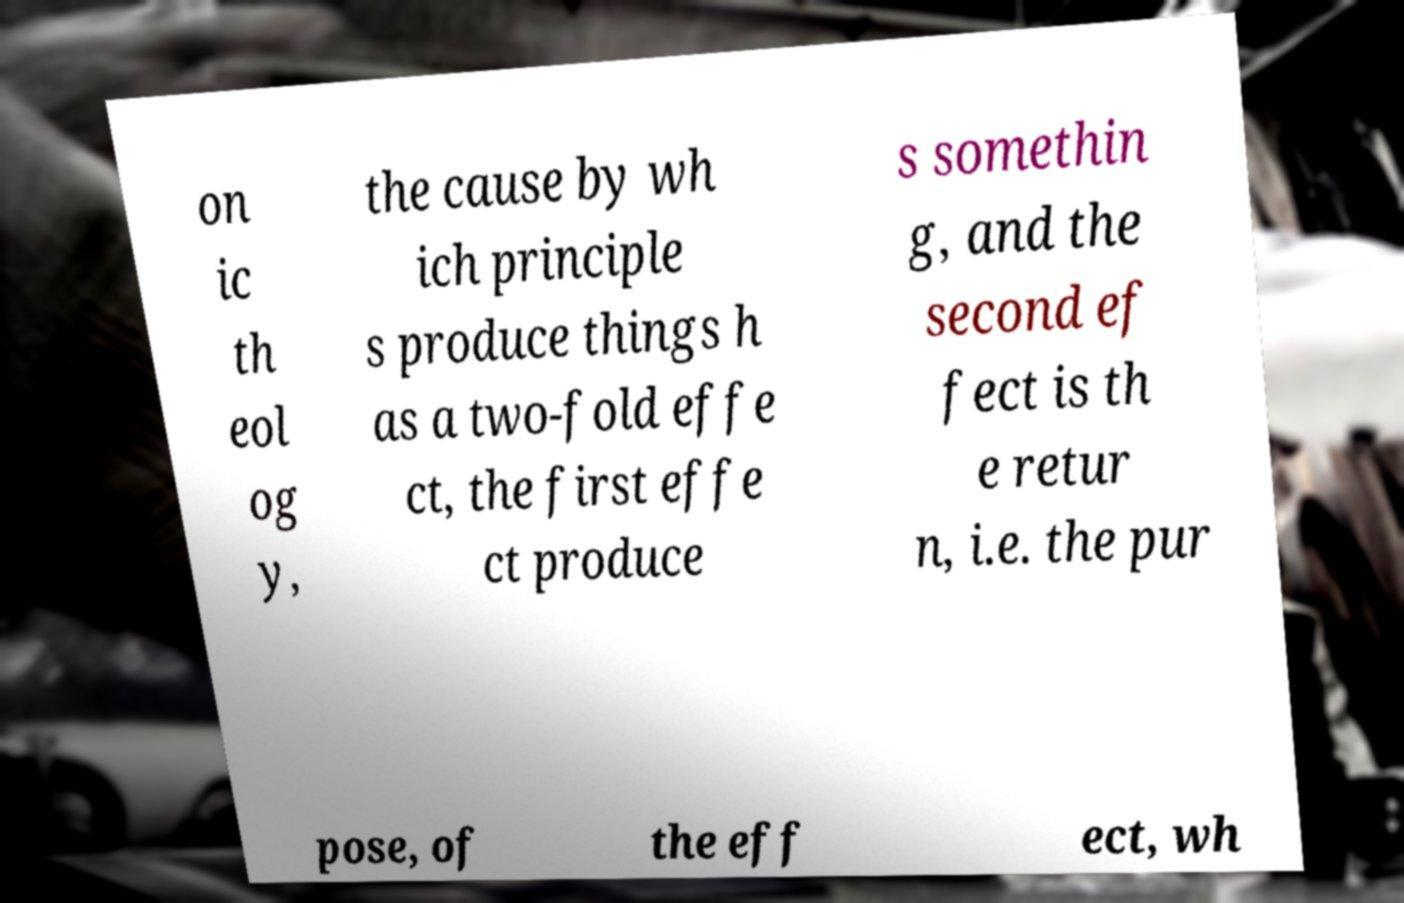Please read and relay the text visible in this image. What does it say? on ic th eol og y, the cause by wh ich principle s produce things h as a two-fold effe ct, the first effe ct produce s somethin g, and the second ef fect is th e retur n, i.e. the pur pose, of the eff ect, wh 